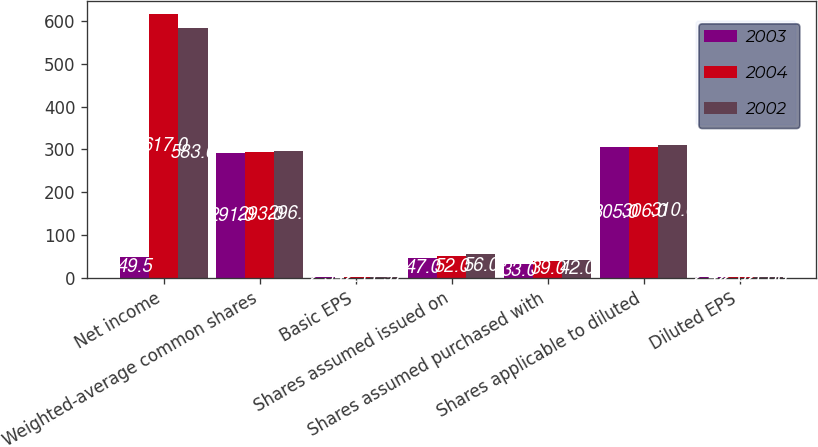Convert chart to OTSL. <chart><loc_0><loc_0><loc_500><loc_500><stacked_bar_chart><ecel><fcel>Net income<fcel>Weighted-average common shares<fcel>Basic EPS<fcel>Shares assumed issued on<fcel>Shares assumed purchased with<fcel>Shares applicable to diluted<fcel>Diluted EPS<nl><fcel>2003<fcel>49.5<fcel>291<fcel>2.54<fcel>47<fcel>33<fcel>305<fcel>2.42<nl><fcel>2004<fcel>617<fcel>293<fcel>2.1<fcel>52<fcel>39<fcel>306<fcel>2.02<nl><fcel>2002<fcel>583<fcel>296<fcel>1.97<fcel>56<fcel>42<fcel>310<fcel>1.88<nl></chart> 